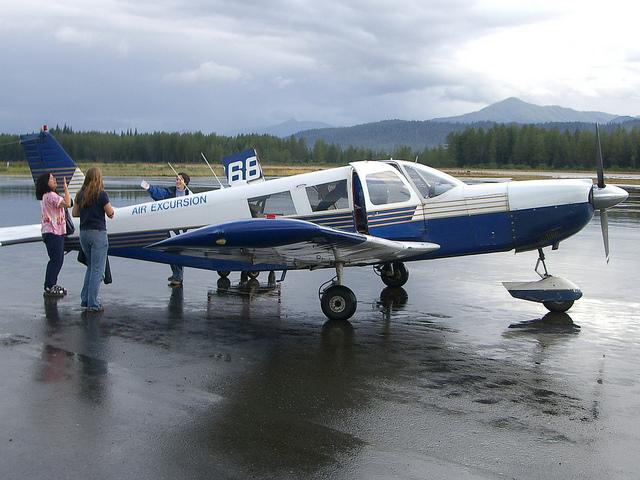Is it a nice day?
Keep it brief. No. What color is the top half of the plane?
Give a very brief answer. White. Where is this scene?
Short answer required. Airport. Is this a big plane?
Write a very short answer. No. What mode of transportation is this?
Write a very short answer. Plane. Are there people outside?
Concise answer only. Yes. Did the plane land in the water?
Be succinct. No. 